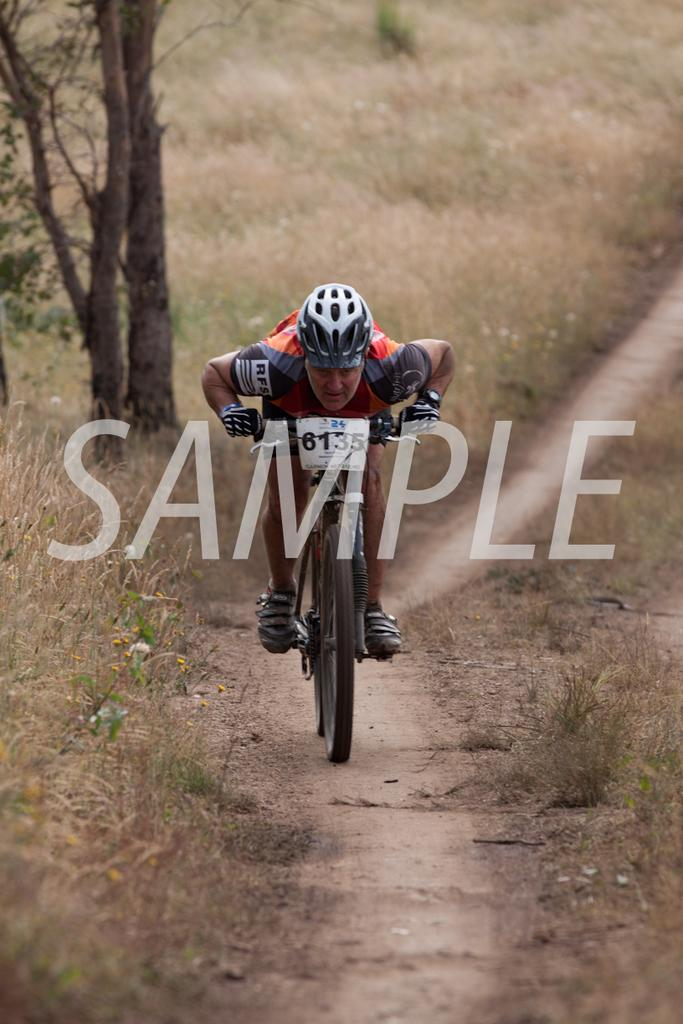What is the person in the image doing? The person is riding a bicycle in the image. Where is the person riding the bicycle? The person is on the road. What can be seen in the background of the image? There are trees and grass in the background of the image. What time of day was the image taken? The image was taken during the day. What type of shock can be seen on the person's face in the image? There is no shock visible on the person's face in the image. What emotion is the person expressing while riding the bicycle? The image does not provide enough information to determine the person's emotional state. 